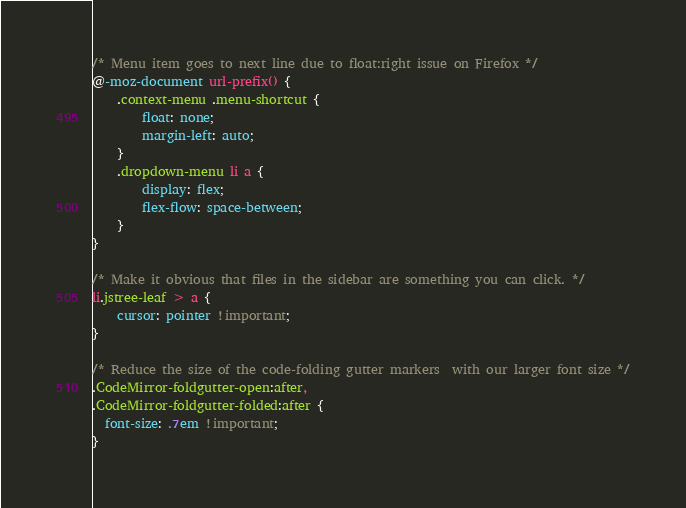<code> <loc_0><loc_0><loc_500><loc_500><_CSS_>/* Menu item goes to next line due to float:right issue on Firefox */
@-moz-document url-prefix() {
	.context-menu .menu-shortcut {
		float: none;
		margin-left: auto;
	}
	.dropdown-menu li a {
		display: flex;
		flex-flow: space-between;
	}
}

/* Make it obvious that files in the sidebar are something you can click. */
li.jstree-leaf > a {
	cursor: pointer !important;
}

/* Reduce the size of the code-folding gutter markers  with our larger font size */
.CodeMirror-foldgutter-open:after,
.CodeMirror-foldgutter-folded:after {
  font-size: .7em !important;
}
</code> 